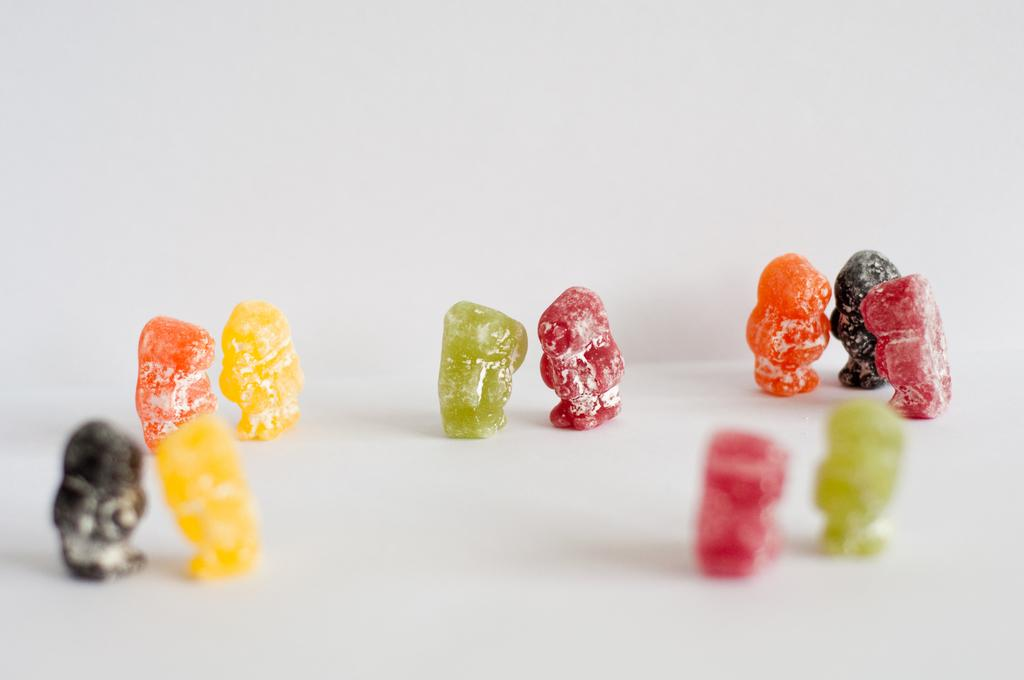What type of food items are present in the image? There are candies in the image. Can you describe the colors of the candies? The candies have various colors, including yellow, orange, black, green, red, and pink. What is the color of the surface on which the candies are placed? The surface on which the candies are placed is white. What type of business is being conducted in the image? There is no indication of a business being conducted in the image; it features candies with various colors on a white surface. Can you see any shoes in the image? There are no shoes present in the image. 